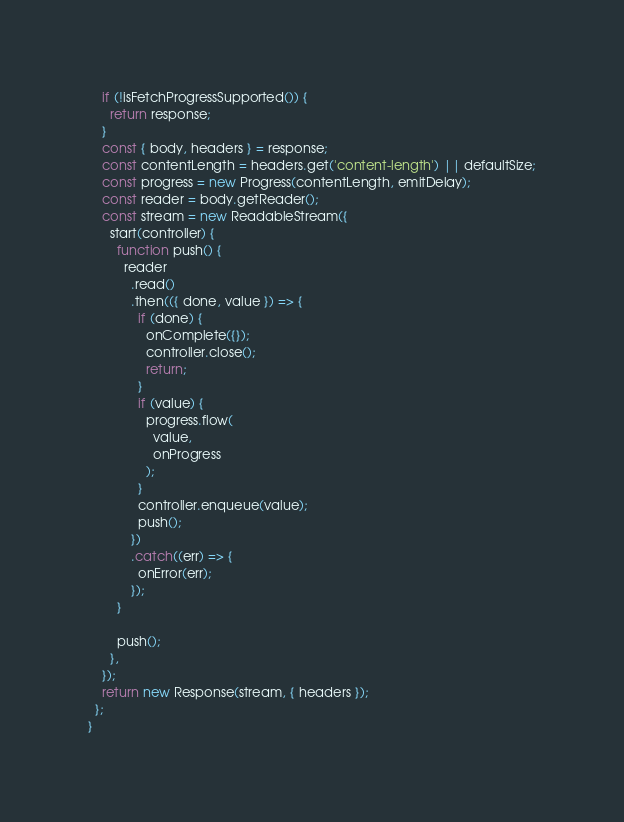Convert code to text. <code><loc_0><loc_0><loc_500><loc_500><_JavaScript_>    if (!isFetchProgressSupported()) {
      return response;
    }
    const { body, headers } = response;
    const contentLength = headers.get('content-length') || defaultSize;
    const progress = new Progress(contentLength, emitDelay);
    const reader = body.getReader();
    const stream = new ReadableStream({
      start(controller) {
        function push() {
          reader
            .read()
            .then(({ done, value }) => {
              if (done) {
                onComplete({});
                controller.close();
                return;
              }
              if (value) {
                progress.flow(
                  value,
                  onProgress
                );
              }
              controller.enqueue(value);
              push();
            })
            .catch((err) => {
              onError(err);
            });
        }

        push();
      },
    });
    return new Response(stream, { headers });
  };
}
</code> 